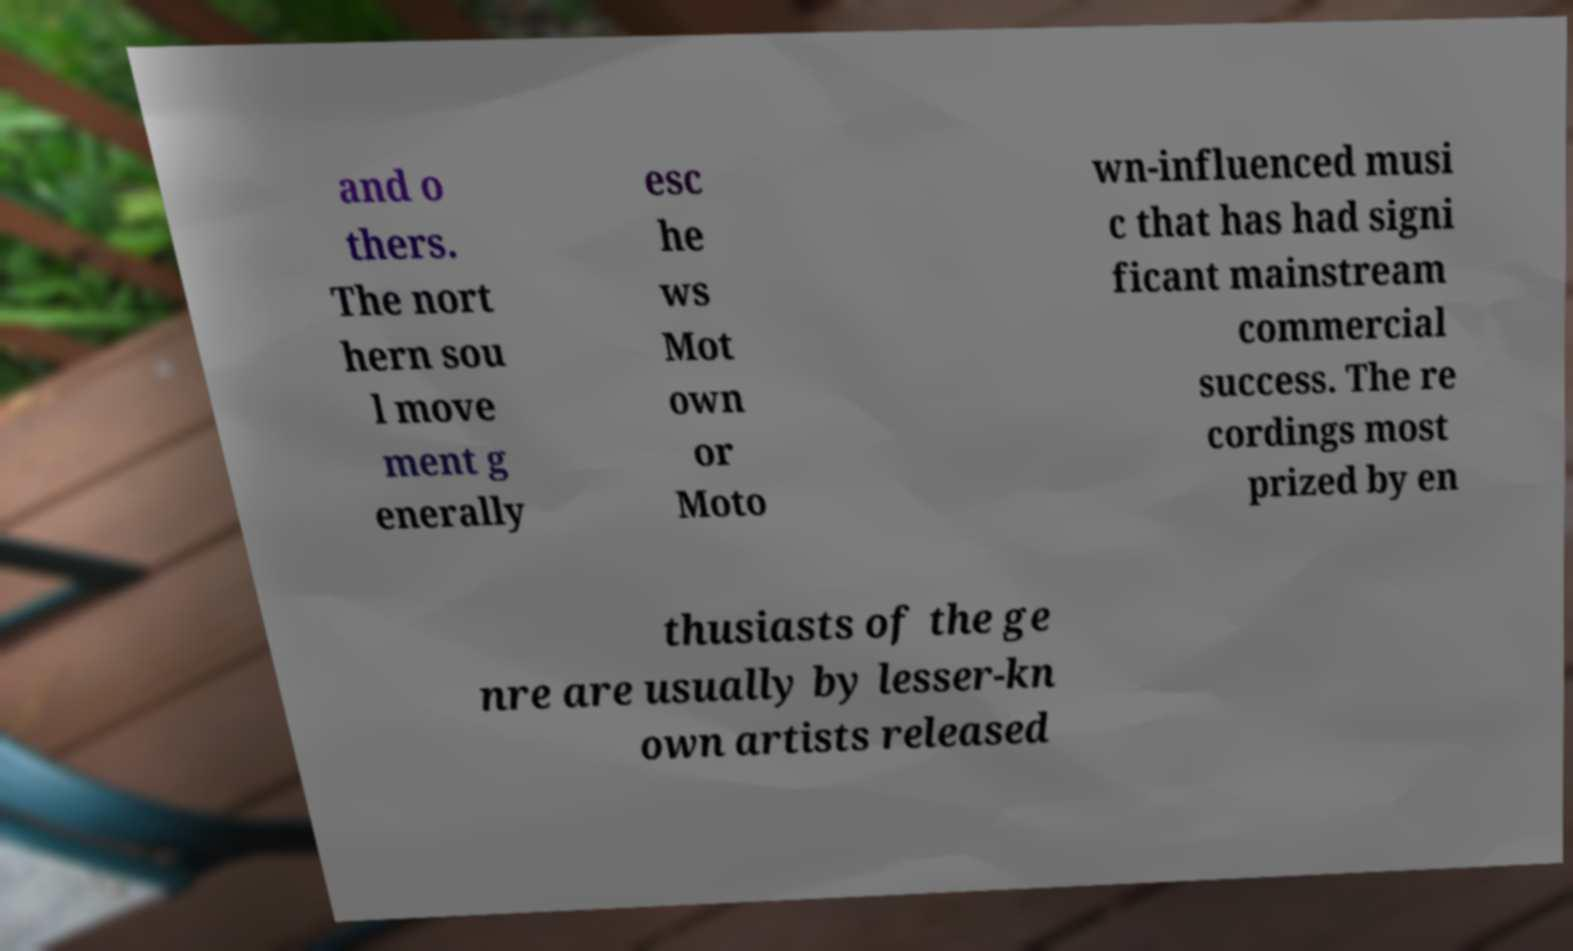There's text embedded in this image that I need extracted. Can you transcribe it verbatim? and o thers. The nort hern sou l move ment g enerally esc he ws Mot own or Moto wn-influenced musi c that has had signi ficant mainstream commercial success. The re cordings most prized by en thusiasts of the ge nre are usually by lesser-kn own artists released 